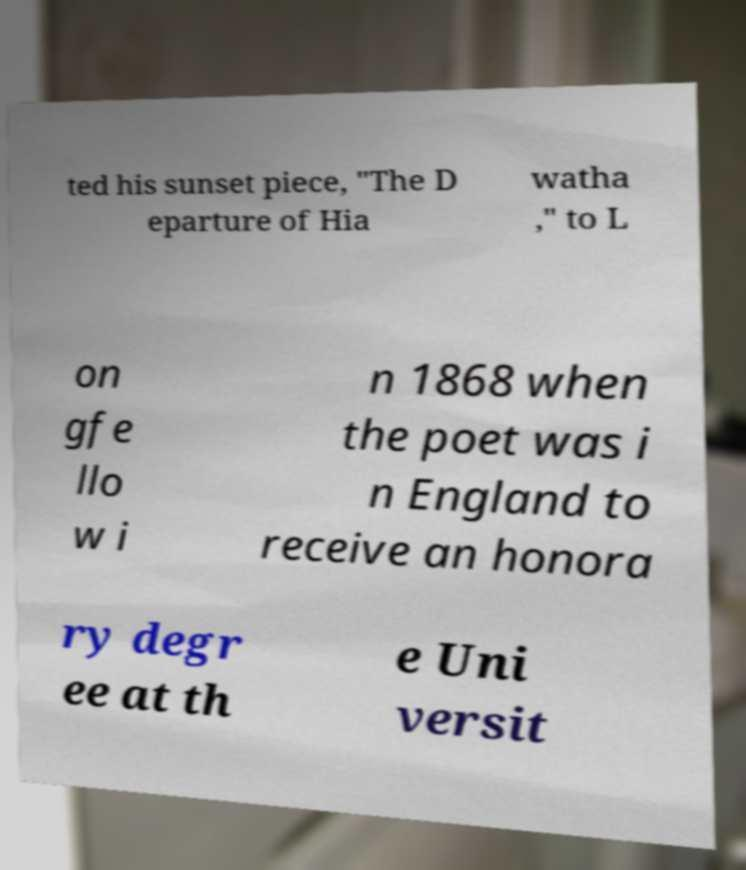Could you assist in decoding the text presented in this image and type it out clearly? ted his sunset piece, "The D eparture of Hia watha ," to L on gfe llo w i n 1868 when the poet was i n England to receive an honora ry degr ee at th e Uni versit 